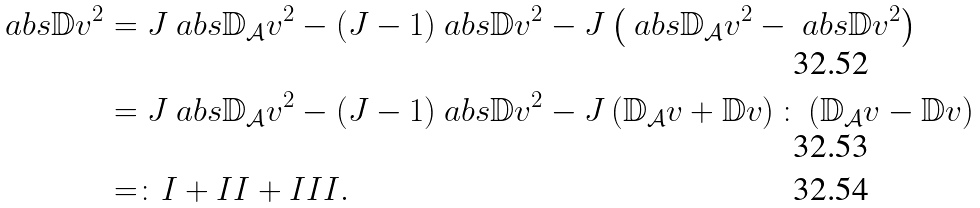Convert formula to latex. <formula><loc_0><loc_0><loc_500><loc_500>\ a b s { \mathbb { D } v } ^ { 2 } & = J \ a b s { \mathbb { D } _ { \mathcal { A } } v } ^ { 2 } - ( J - 1 ) \ a b s { \mathbb { D } v } ^ { 2 } - J \left ( \ a b s { \mathbb { D } _ { \mathcal { A } } v } ^ { 2 } - \ a b s { \mathbb { D } v } ^ { 2 } \right ) \\ & = J \ a b s { \mathbb { D } _ { \mathcal { A } } v } ^ { 2 } - ( J - 1 ) \ a b s { \mathbb { D } v } ^ { 2 } - J \left ( \mathbb { D } _ { \mathcal { A } } v + \mathbb { D } v \right ) \colon \left ( \mathbb { D } _ { \mathcal { A } } v - \mathbb { D } v \right ) \\ & = \colon I + I I + I I I .</formula> 